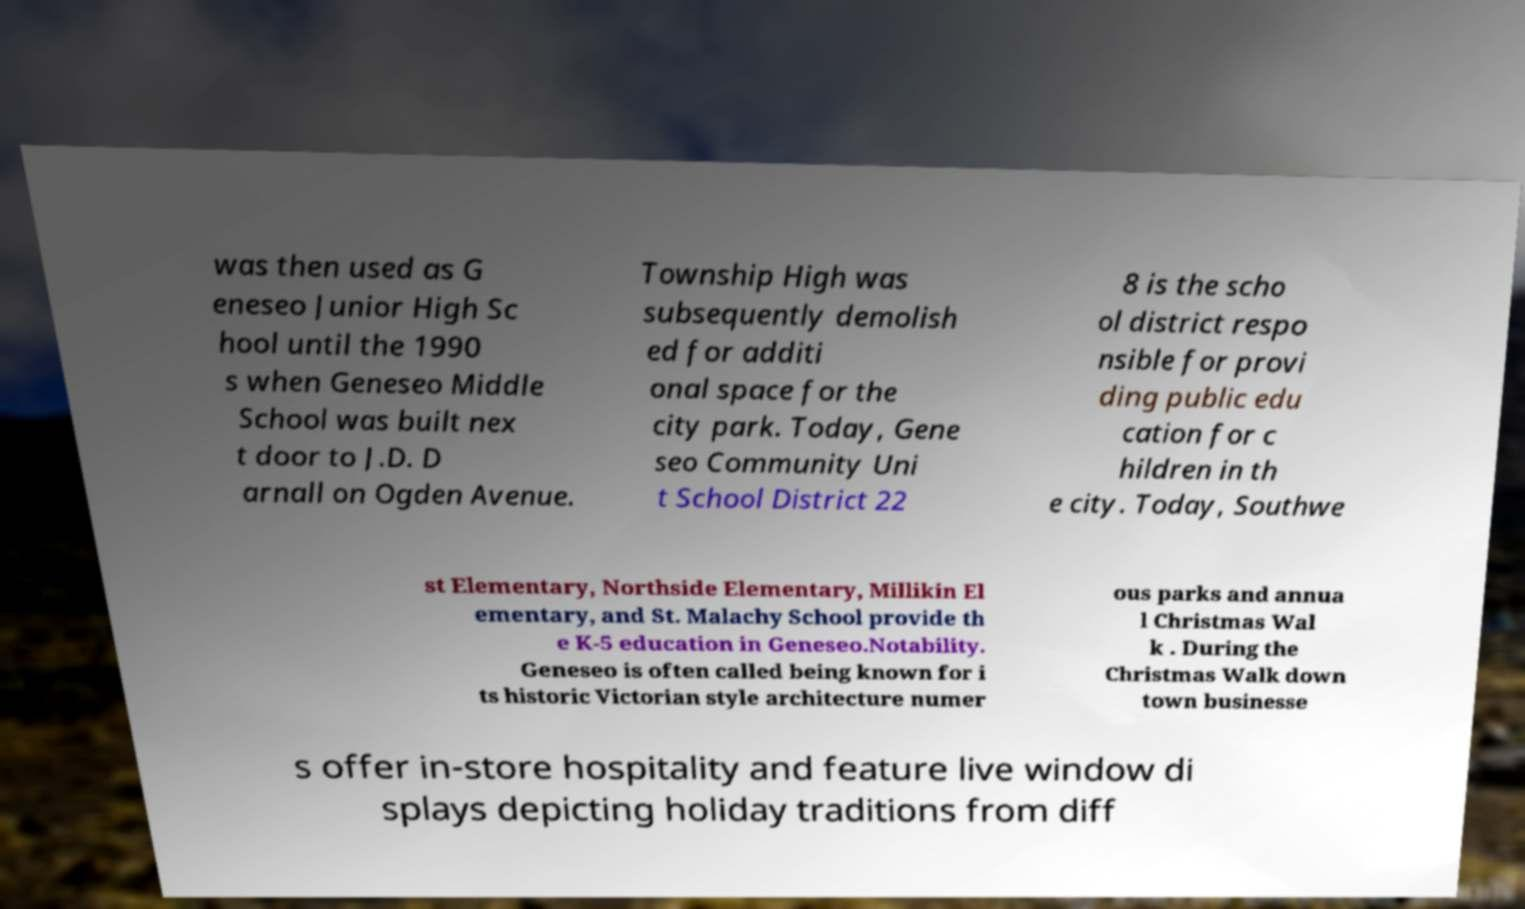Could you extract and type out the text from this image? was then used as G eneseo Junior High Sc hool until the 1990 s when Geneseo Middle School was built nex t door to J.D. D arnall on Ogden Avenue. Township High was subsequently demolish ed for additi onal space for the city park. Today, Gene seo Community Uni t School District 22 8 is the scho ol district respo nsible for provi ding public edu cation for c hildren in th e city. Today, Southwe st Elementary, Northside Elementary, Millikin El ementary, and St. Malachy School provide th e K-5 education in Geneseo.Notability. Geneseo is often called being known for i ts historic Victorian style architecture numer ous parks and annua l Christmas Wal k . During the Christmas Walk down town businesse s offer in-store hospitality and feature live window di splays depicting holiday traditions from diff 